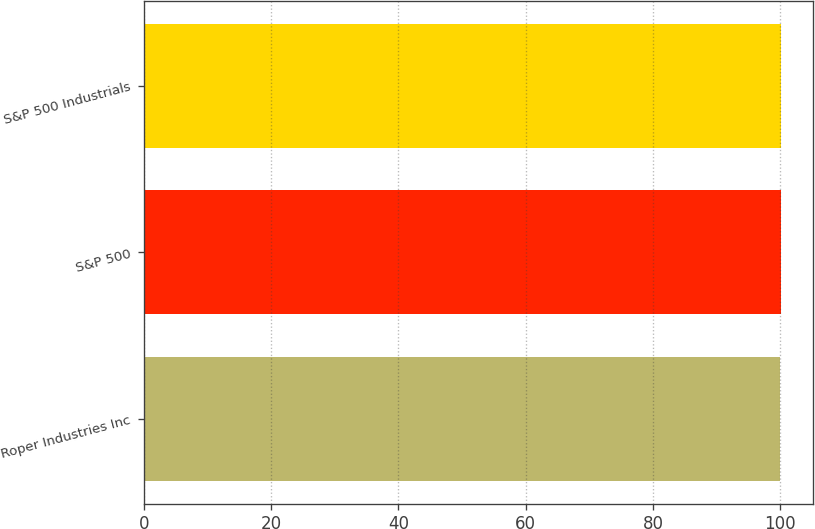<chart> <loc_0><loc_0><loc_500><loc_500><bar_chart><fcel>Roper Industries Inc<fcel>S&P 500<fcel>S&P 500 Industrials<nl><fcel>100<fcel>100.1<fcel>100.2<nl></chart> 